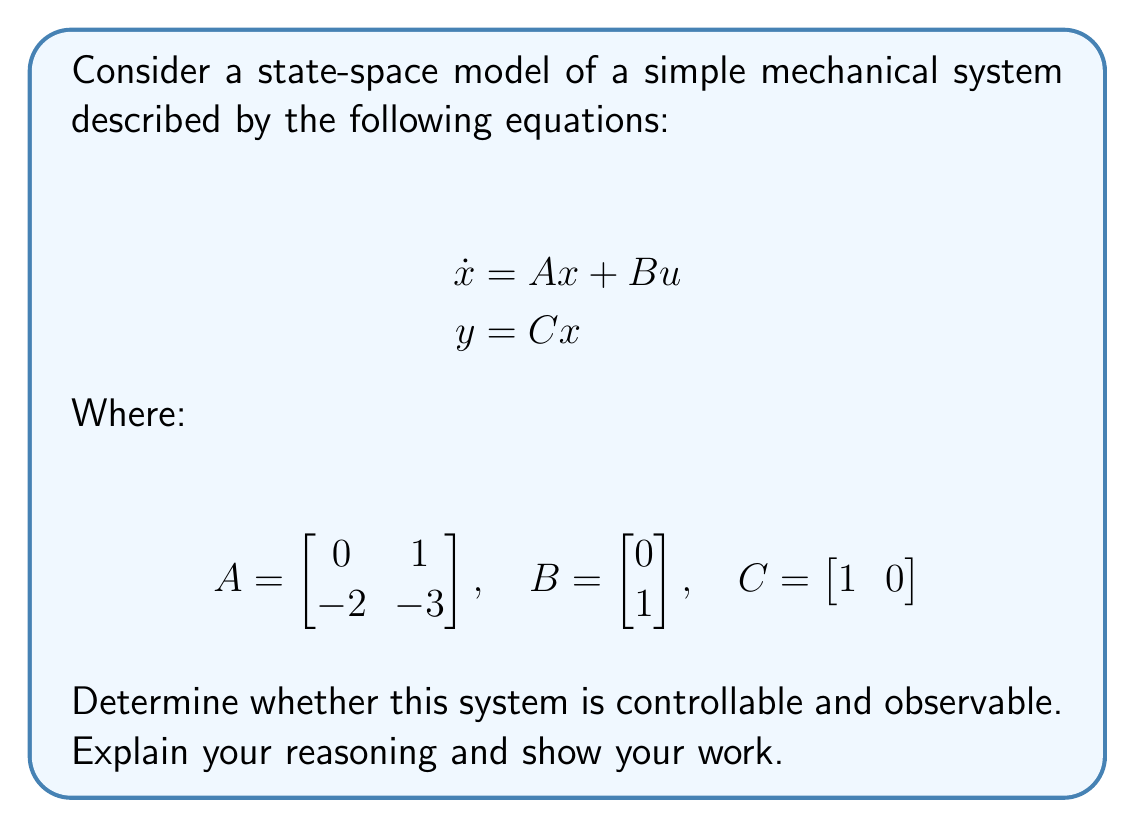Can you solve this math problem? To determine the controllability and observability of this state-space model, we need to use the controllability and observability matrices.

1. Controllability:
The controllability matrix is defined as:

$$C_o = [B \quad AB \quad A^2B \quad ... \quad A^{n-1}B]$$

Where n is the number of states (in this case, n = 2).

Let's calculate:

$$B = \begin{bmatrix}
0 \\
1
\end{bmatrix}$$

$$AB = \begin{bmatrix}
0 & 1 \\
-2 & -3
\end{bmatrix} \begin{bmatrix}
0 \\
1
\end{bmatrix} = \begin{bmatrix}
1 \\
-3
\end{bmatrix}$$

Therefore, the controllability matrix is:

$$C_o = [B \quad AB] = \begin{bmatrix}
0 & 1 \\
1 & -3
\end{bmatrix}$$

The system is controllable if and only if the rank of $C_o$ is equal to the number of states (n = 2).

To check the rank, we can calculate the determinant:

$$\det(C_o) = 0 \cdot (-3) - 1 \cdot 1 = -1 \neq 0$$

Since the determinant is non-zero, the rank of $C_o$ is 2, which is equal to the number of states. Therefore, the system is controllable.

2. Observability:
The observability matrix is defined as:

$$O_b = \begin{bmatrix}
C \\
CA \\
CA^2 \\
\vdots \\
CA^{n-1}
\end{bmatrix}$$

Let's calculate:

$$C = \begin{bmatrix}
1 & 0
\end{bmatrix}$$

$$CA = \begin{bmatrix}
1 & 0
\end{bmatrix} \begin{bmatrix}
0 & 1 \\
-2 & -3
\end{bmatrix} = \begin{bmatrix}
0 & 1
\end{bmatrix}$$

Therefore, the observability matrix is:

$$O_b = \begin{bmatrix}
C \\
CA
\end{bmatrix} = \begin{bmatrix}
1 & 0 \\
0 & 1
\end{bmatrix}$$

The system is observable if and only if the rank of $O_b$ is equal to the number of states (n = 2).

The observability matrix $O_b$ is clearly the identity matrix, which has full rank (rank = 2). Therefore, the system is observable.
Answer: The system is both controllable and observable. 